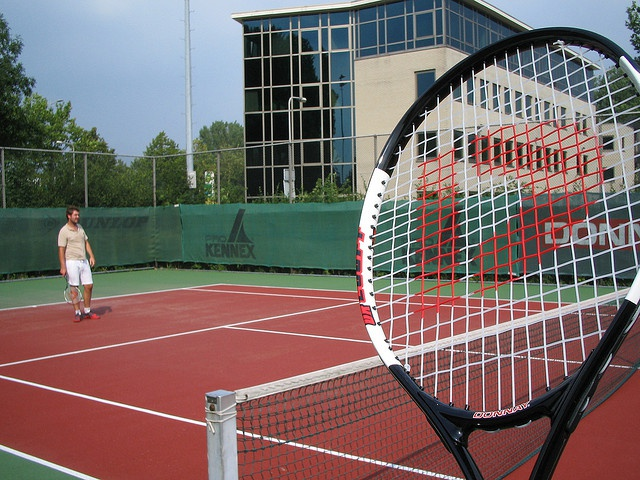Describe the objects in this image and their specific colors. I can see tennis racket in darkgray, black, lightgray, and gray tones, people in darkgray, lightgray, tan, and brown tones, and tennis racket in darkgray and gray tones in this image. 